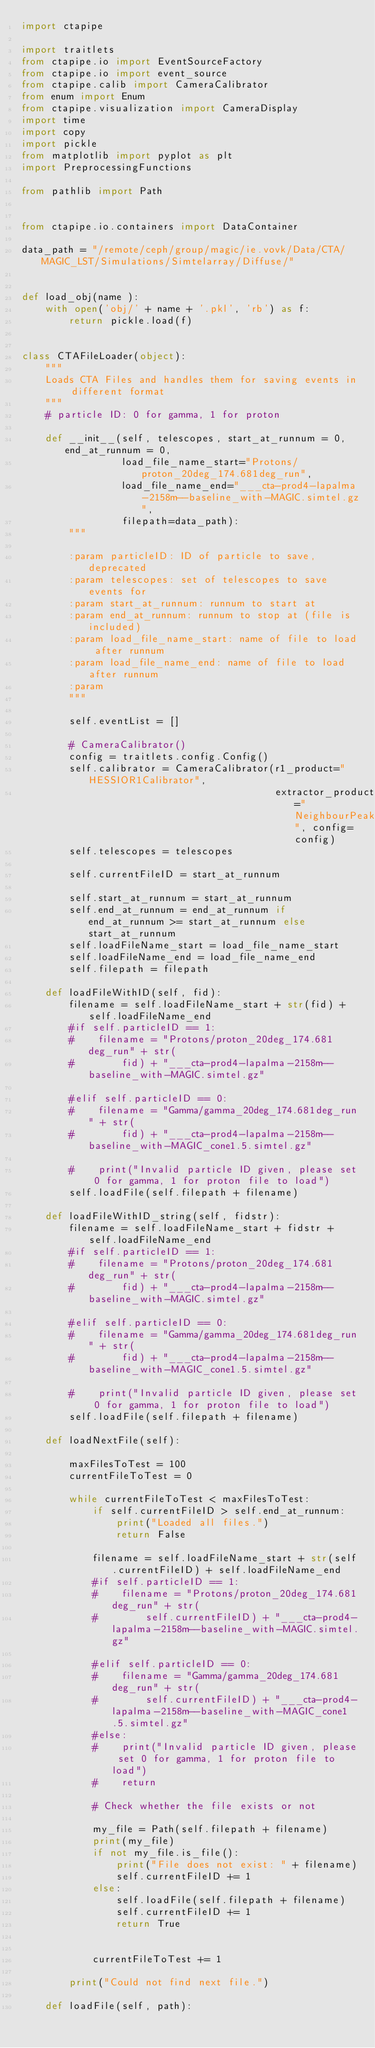Convert code to text. <code><loc_0><loc_0><loc_500><loc_500><_Python_>import ctapipe

import traitlets
from ctapipe.io import EventSourceFactory
from ctapipe.io import event_source
from ctapipe.calib import CameraCalibrator
from enum import Enum
from ctapipe.visualization import CameraDisplay
import time
import copy
import pickle
from matplotlib import pyplot as plt
import PreprocessingFunctions

from pathlib import Path


from ctapipe.io.containers import DataContainer

data_path = "/remote/ceph/group/magic/ie.vovk/Data/CTA/MAGIC_LST/Simulations/Simtelarray/Diffuse/"


def load_obj(name ):
    with open('obj/' + name + '.pkl', 'rb') as f:
        return pickle.load(f)


class CTAFileLoader(object):
    """
    Loads CTA Files and handles them for saving events in different format
    """
    # particle ID: 0 for gamma, 1 for proton

    def __init__(self, telescopes, start_at_runnum = 0, end_at_runnum = 0,
                 load_file_name_start="Protons/proton_20deg_174.681deg_run",
                 load_file_name_end="___cta-prod4-lapalma-2158m--baseline_with-MAGIC.simtel.gz",
                 filepath=data_path):
        """

        :param particleID: ID of particle to save, deprecated
        :param telescopes: set of telescopes to save events for
        :param start_at_runnum: runnum to start at
        :param end_at_runnum: runnum to stop at (file is included)
        :param load_file_name_start: name of file to load after runnum
        :param load_file_name_end: name of file to load after runnum
        :param
        """

        self.eventList = []

        # CameraCalibrator()
        config = traitlets.config.Config()
        self.calibrator = CameraCalibrator(r1_product="HESSIOR1Calibrator",
                                           extractor_product="NeighbourPeakIntegrator", config=config)
        self.telescopes = telescopes

        self.currentFileID = start_at_runnum

        self.start_at_runnum = start_at_runnum
        self.end_at_runnum = end_at_runnum if end_at_runnum >= start_at_runnum else start_at_runnum
        self.loadFileName_start = load_file_name_start
        self.loadFileName_end = load_file_name_end
        self.filepath = filepath

    def loadFileWithID(self, fid):
        filename = self.loadFileName_start + str(fid) + self.loadFileName_end
        #if self.particleID == 1:
        #    filename = "Protons/proton_20deg_174.681deg_run" + str(
        #        fid) + "___cta-prod4-lapalma-2158m--baseline_with-MAGIC.simtel.gz"

        #elif self.particleID == 0:
        #    filename = "Gamma/gamma_20deg_174.681deg_run" + str(
        #        fid) + "___cta-prod4-lapalma-2158m--baseline_with-MAGIC_cone1.5.simtel.gz"

        #    print("Invalid particle ID given, please set 0 for gamma, 1 for proton file to load")
        self.loadFile(self.filepath + filename)

    def loadFileWithID_string(self, fidstr):
        filename = self.loadFileName_start + fidstr + self.loadFileName_end
        #if self.particleID == 1:
        #    filename = "Protons/proton_20deg_174.681deg_run" + str(
        #        fid) + "___cta-prod4-lapalma-2158m--baseline_with-MAGIC.simtel.gz"

        #elif self.particleID == 0:
        #    filename = "Gamma/gamma_20deg_174.681deg_run" + str(
        #        fid) + "___cta-prod4-lapalma-2158m--baseline_with-MAGIC_cone1.5.simtel.gz"

        #    print("Invalid particle ID given, please set 0 for gamma, 1 for proton file to load")
        self.loadFile(self.filepath + filename)

    def loadNextFile(self):

        maxFilesToTest = 100
        currentFileToTest = 0

        while currentFileToTest < maxFilesToTest:
            if self.currentFileID > self.end_at_runnum:
                print("Loaded all files.")
                return False

            filename = self.loadFileName_start + str(self.currentFileID) + self.loadFileName_end
            #if self.particleID == 1:
            #    filename = "Protons/proton_20deg_174.681deg_run" + str(
            #        self.currentFileID) + "___cta-prod4-lapalma-2158m--baseline_with-MAGIC.simtel.gz"

            #elif self.particleID == 0:
            #    filename = "Gamma/gamma_20deg_174.681deg_run" + str(
            #        self.currentFileID) + "___cta-prod4-lapalma-2158m--baseline_with-MAGIC_cone1.5.simtel.gz"
            #else:
            #    print("Invalid particle ID given, please set 0 for gamma, 1 for proton file to load")
            #    return

            # Check whether the file exists or not

            my_file = Path(self.filepath + filename)
            print(my_file)
            if not my_file.is_file():
                print("File does not exist: " + filename)
                self.currentFileID += 1
            else:
                self.loadFile(self.filepath + filename)
                self.currentFileID += 1
                return True


            currentFileToTest += 1

        print("Could not find next file.")

    def loadFile(self, path):</code> 